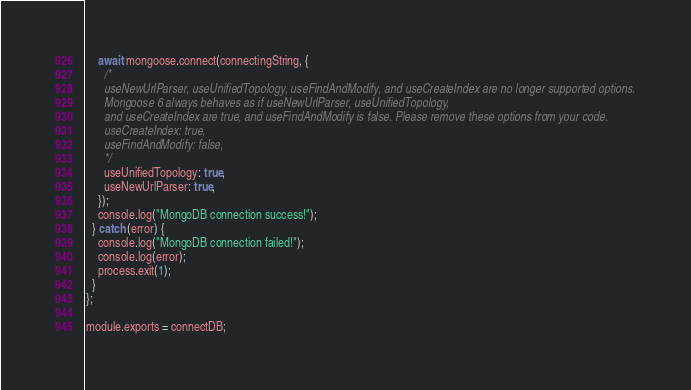<code> <loc_0><loc_0><loc_500><loc_500><_JavaScript_>    await mongoose.connect(connectingString, {
      /*
      useNewUrlParser, useUnifiedTopology, useFindAndModify, and useCreateIndex are no longer supported options.
      Mongoose 6 always behaves as if useNewUrlParser, useUnifiedTopology,
      and useCreateIndex are true, and useFindAndModify is false. Please remove these options from your code.
      useCreateIndex: true,
      useFindAndModify: false,
      */
      useUnifiedTopology: true,
      useNewUrlParser: true,
    });
    console.log("MongoDB connection success!");
  } catch (error) {
    console.log("MongoDB connection failed!");
    console.log(error);
    process.exit(1);
  }
};

module.exports = connectDB;
</code> 